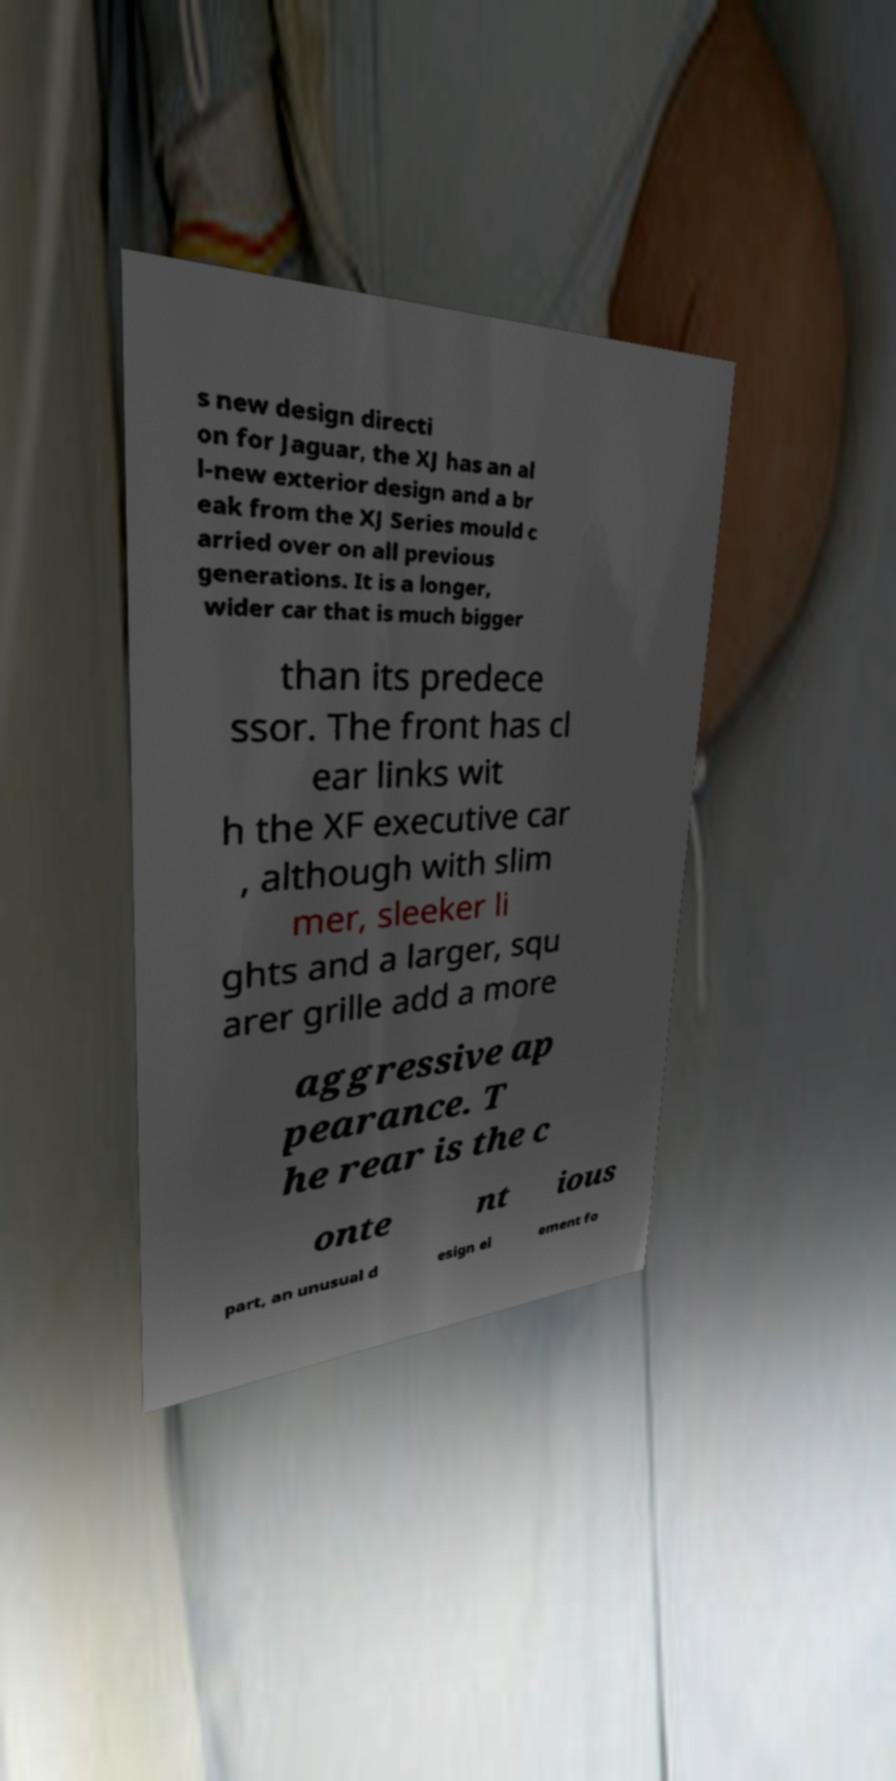Please identify and transcribe the text found in this image. s new design directi on for Jaguar, the XJ has an al l-new exterior design and a br eak from the XJ Series mould c arried over on all previous generations. It is a longer, wider car that is much bigger than its predece ssor. The front has cl ear links wit h the XF executive car , although with slim mer, sleeker li ghts and a larger, squ arer grille add a more aggressive ap pearance. T he rear is the c onte nt ious part, an unusual d esign el ement fo 